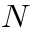<formula> <loc_0><loc_0><loc_500><loc_500>N</formula> 